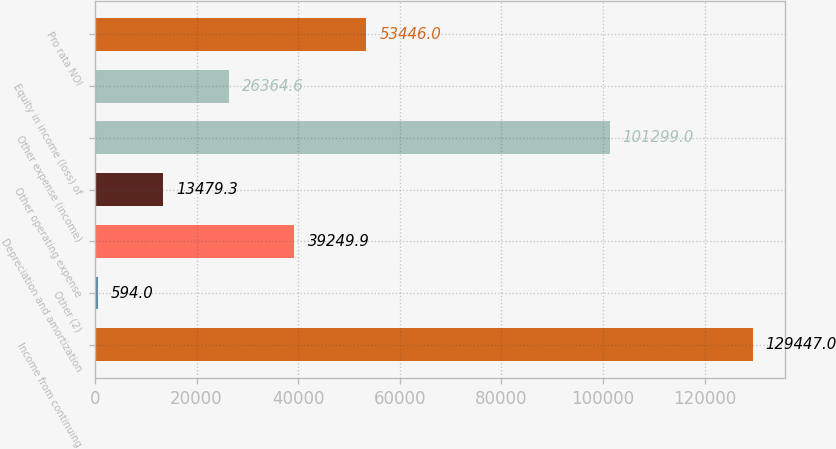<chart> <loc_0><loc_0><loc_500><loc_500><bar_chart><fcel>Income from continuing<fcel>Other (2)<fcel>Depreciation and amortization<fcel>Other operating expense<fcel>Other expense (income)<fcel>Equity in income (loss) of<fcel>Pro rata NOI<nl><fcel>129447<fcel>594<fcel>39249.9<fcel>13479.3<fcel>101299<fcel>26364.6<fcel>53446<nl></chart> 